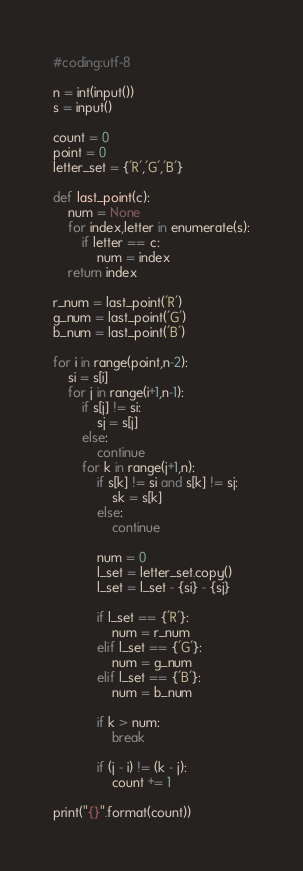Convert code to text. <code><loc_0><loc_0><loc_500><loc_500><_Python_>#coding:utf-8

n = int(input())
s = input()

count = 0
point = 0
letter_set = {'R','G','B'}

def last_point(c):
    num = None
    for index,letter in enumerate(s):
        if letter == c:
            num = index
    return index

r_num = last_point('R')
g_num = last_point('G')
b_num = last_point('B')

for i in range(point,n-2):
    si = s[i]
    for j in range(i+1,n-1):
        if s[j] != si:
            sj = s[j]
        else:
            continue
        for k in range(j+1,n):
            if s[k] != si and s[k] != sj:
                sk = s[k]
            else:
                continue
            
            num = 0
            l_set = letter_set.copy()
            l_set = l_set - {si} - {sj}
            
            if l_set == {'R'}:
                num = r_num
            elif l_set == {'G'}:
                num = g_num
            elif l_set == {'B'}:
                num = b_num

            if k > num:
                break
            
            if (j - i) != (k - j):
                count += 1

print("{}".format(count))</code> 